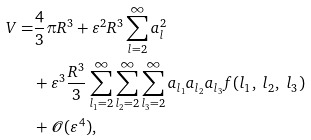<formula> <loc_0><loc_0><loc_500><loc_500>V = & \frac { 4 } { 3 } \pi R ^ { 3 } + \varepsilon ^ { 2 } R ^ { 3 } \sum _ { l = 2 } ^ { \infty } a _ { l } ^ { 2 } \\ & + \varepsilon ^ { 3 } \frac { R ^ { 3 } } { 3 } \sum _ { l _ { 1 } = 2 } ^ { \infty } \sum _ { l _ { 2 } = 2 } ^ { \infty } \sum _ { l _ { 3 } = 2 } ^ { \infty } a _ { l _ { 1 } } a _ { l _ { 2 } } a _ { l _ { 3 } } f ( l _ { 1 } , \ l _ { 2 } , \ l _ { 3 } ) \\ & + \mathcal { O } ( \varepsilon ^ { 4 } ) ,</formula> 